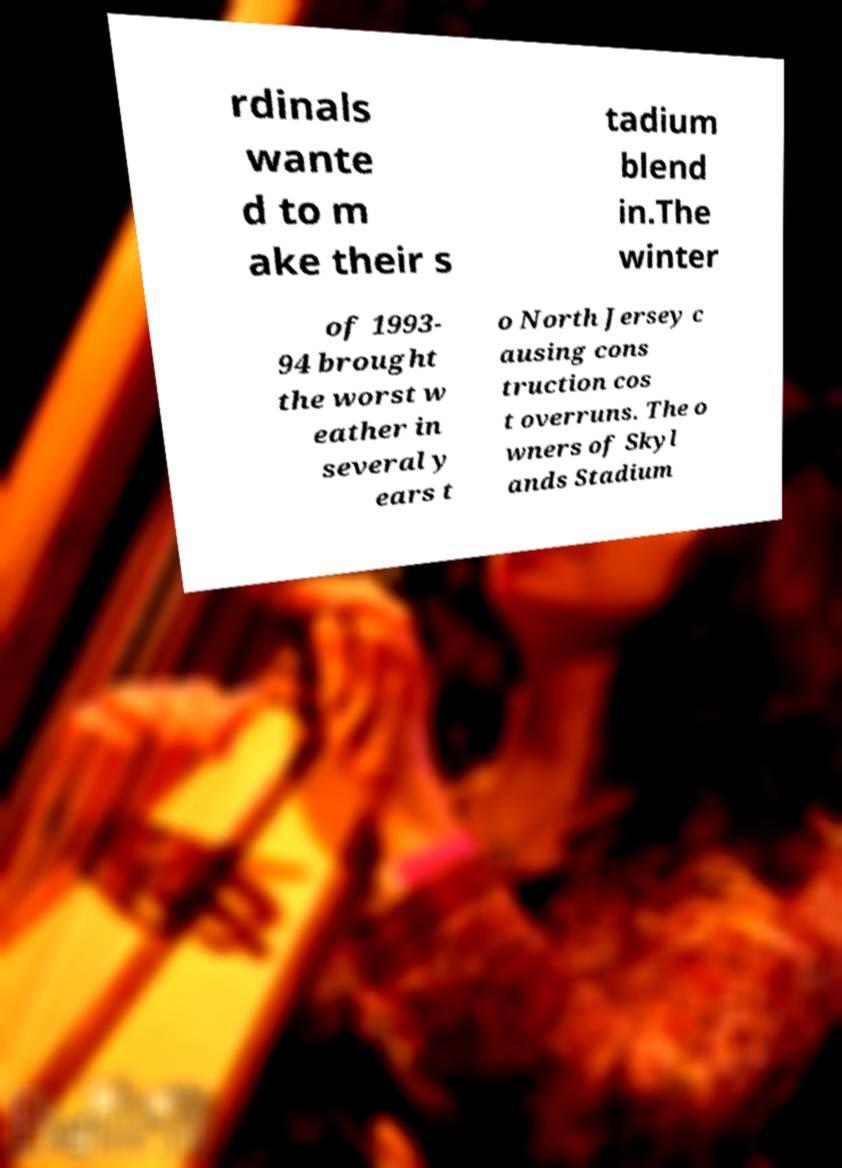I need the written content from this picture converted into text. Can you do that? rdinals wante d to m ake their s tadium blend in.The winter of 1993- 94 brought the worst w eather in several y ears t o North Jersey c ausing cons truction cos t overruns. The o wners of Skyl ands Stadium 